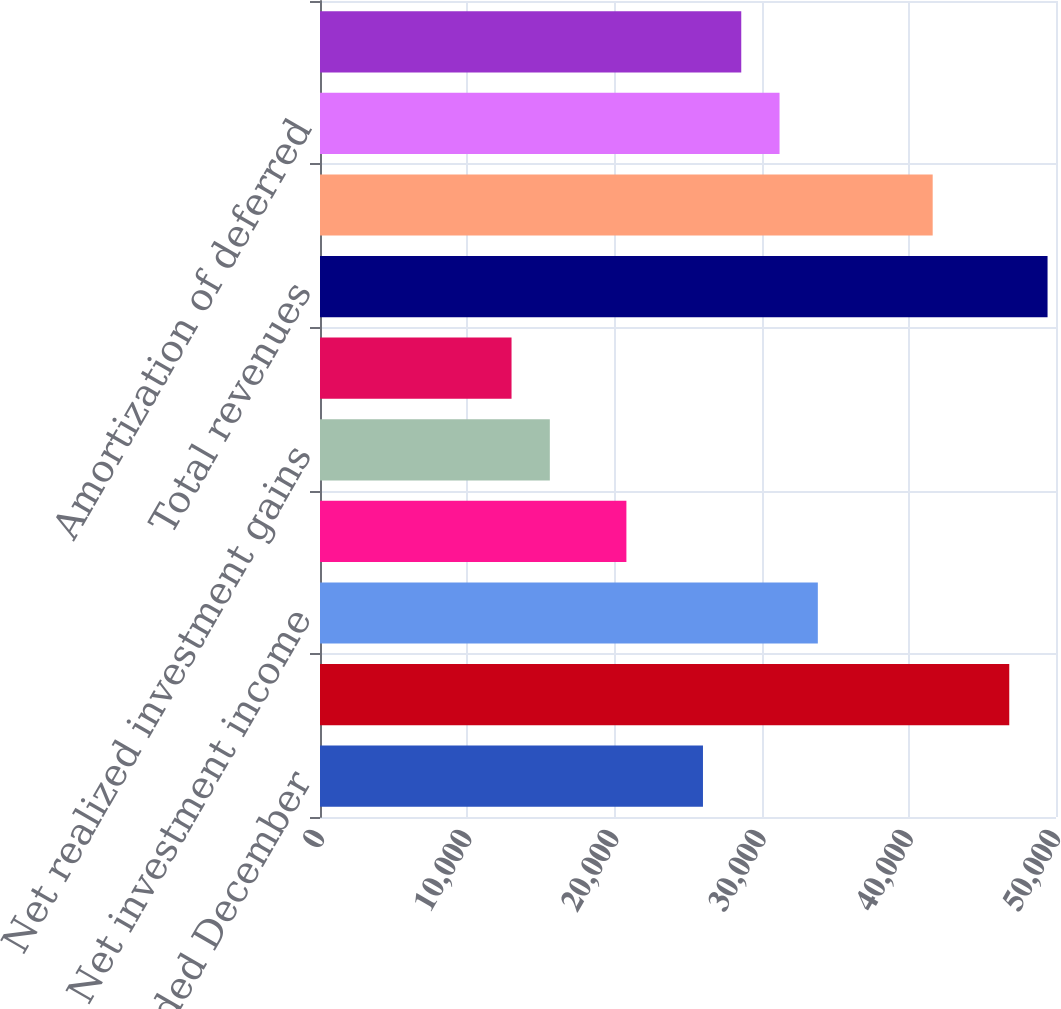<chart> <loc_0><loc_0><loc_500><loc_500><bar_chart><fcel>(for the year ended December<fcel>Premiums<fcel>Net investment income<fcel>Fee income<fcel>Net realized investment gains<fcel>Other revenues<fcel>Total revenues<fcel>Claims and claim adjustment<fcel>Amortization of deferred<fcel>General and administrative<nl><fcel>26017<fcel>46825<fcel>33820<fcel>20814.9<fcel>15612.9<fcel>13011.9<fcel>49426.1<fcel>41623<fcel>31219<fcel>28618<nl></chart> 